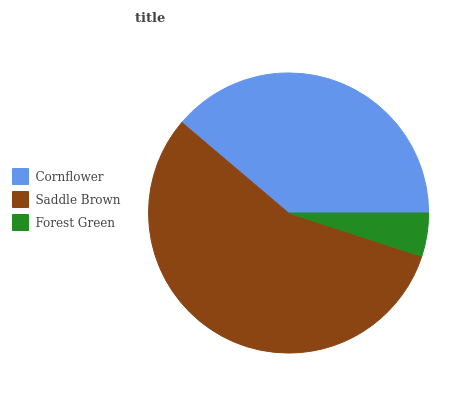Is Forest Green the minimum?
Answer yes or no. Yes. Is Saddle Brown the maximum?
Answer yes or no. Yes. Is Saddle Brown the minimum?
Answer yes or no. No. Is Forest Green the maximum?
Answer yes or no. No. Is Saddle Brown greater than Forest Green?
Answer yes or no. Yes. Is Forest Green less than Saddle Brown?
Answer yes or no. Yes. Is Forest Green greater than Saddle Brown?
Answer yes or no. No. Is Saddle Brown less than Forest Green?
Answer yes or no. No. Is Cornflower the high median?
Answer yes or no. Yes. Is Cornflower the low median?
Answer yes or no. Yes. Is Saddle Brown the high median?
Answer yes or no. No. Is Forest Green the low median?
Answer yes or no. No. 